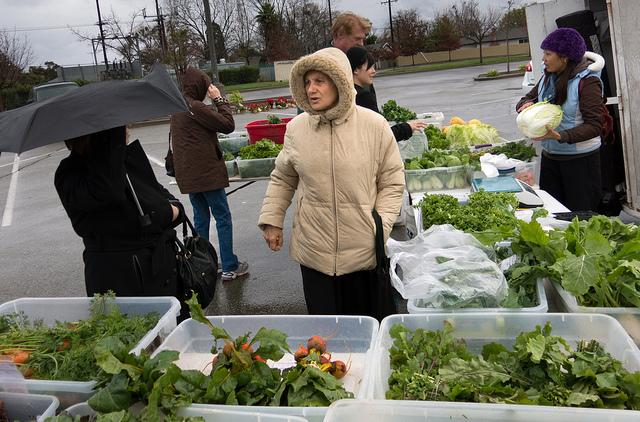What is the woman on the right holding in her hand? Please explain your reasoning. cabbage. She has a cabbage in her hand that she is probably going to sell. 